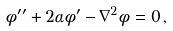Convert formula to latex. <formula><loc_0><loc_0><loc_500><loc_500>\phi ^ { \prime \prime } + 2 \alpha \phi ^ { \prime } - \nabla ^ { 2 } \phi = 0 \, ,</formula> 